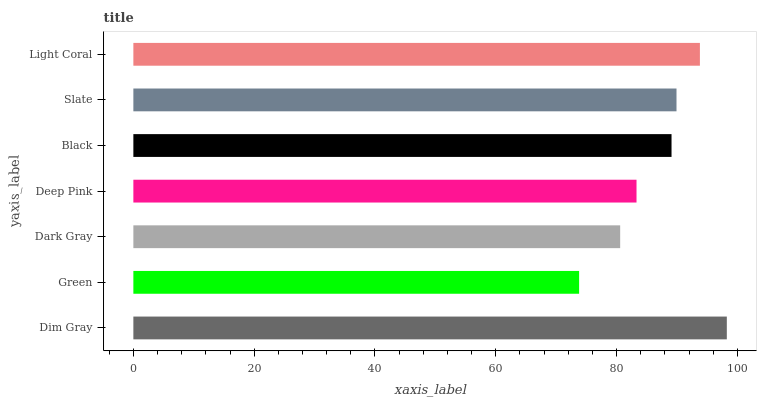Is Green the minimum?
Answer yes or no. Yes. Is Dim Gray the maximum?
Answer yes or no. Yes. Is Dark Gray the minimum?
Answer yes or no. No. Is Dark Gray the maximum?
Answer yes or no. No. Is Dark Gray greater than Green?
Answer yes or no. Yes. Is Green less than Dark Gray?
Answer yes or no. Yes. Is Green greater than Dark Gray?
Answer yes or no. No. Is Dark Gray less than Green?
Answer yes or no. No. Is Black the high median?
Answer yes or no. Yes. Is Black the low median?
Answer yes or no. Yes. Is Slate the high median?
Answer yes or no. No. Is Dim Gray the low median?
Answer yes or no. No. 